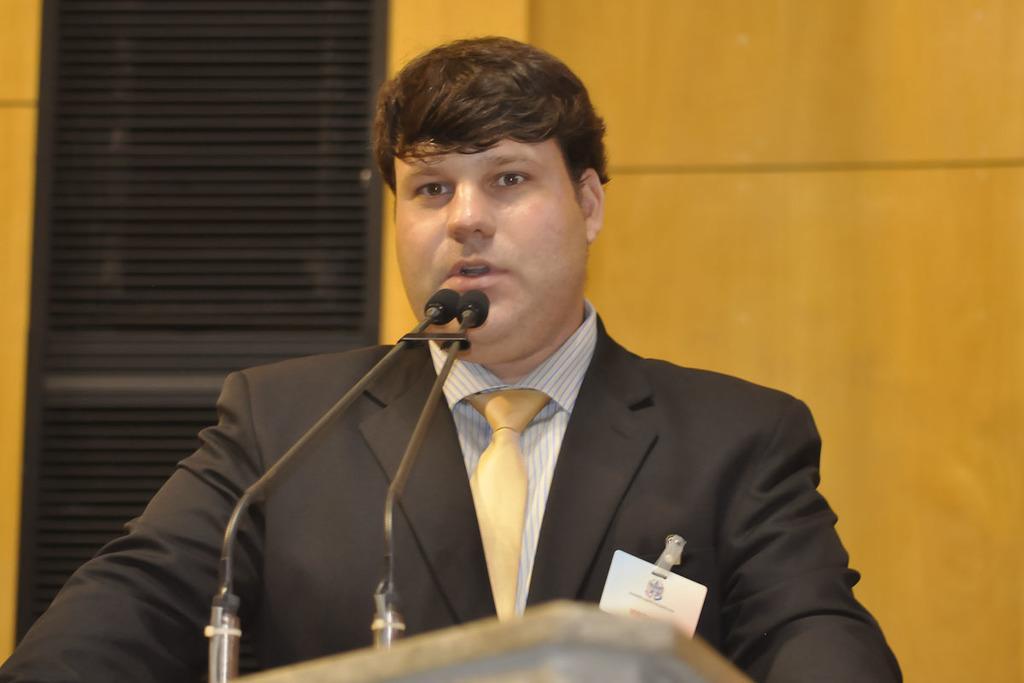How would you summarize this image in a sentence or two? In this image, I can see the man standing. These are the mikes. In the background, I can see the wall. At the bottom of the image, It looks like a podium. 